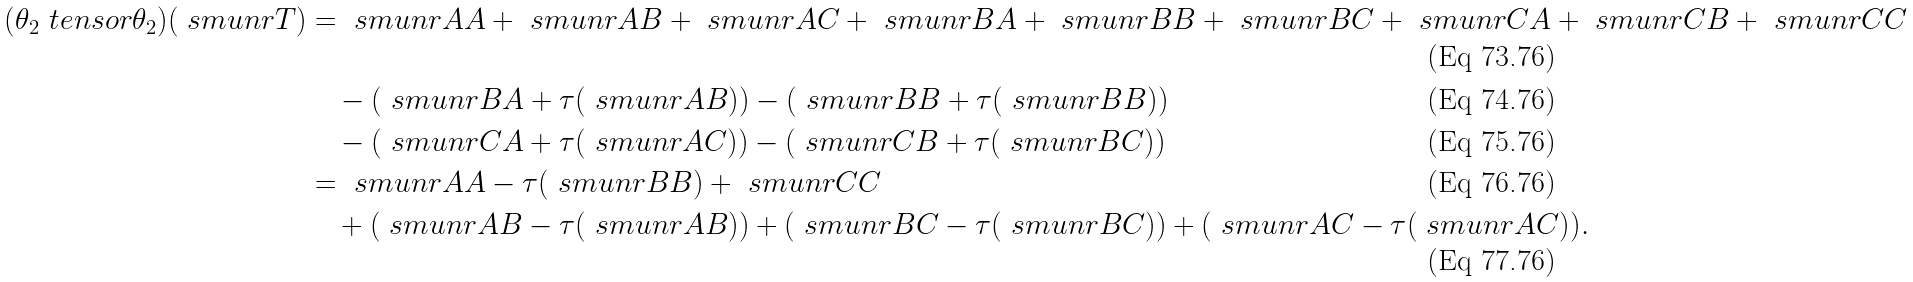Convert formula to latex. <formula><loc_0><loc_0><loc_500><loc_500>( \theta _ { 2 } \ t e n s o r \theta _ { 2 } ) ( \ s m u n { r } { T } ) & = \ s m u n { r } { A A } + \ s m u n { r } { A B } + \ s m u n { r } { A C } + \ s m u n { r } { B A } + \ s m u n { r } { B B } + \ s m u n { r } { B C } + \ s m u n { r } { C A } + \ s m u n { r } { C B } + \ s m u n { r } { C C } \\ & \quad - ( \ s m u n { r } { B A } + \tau ( \ s m u n { r } { A B } ) ) - ( \ s m u n { r } { B B } + \tau ( \ s m u n { r } { B B } ) ) \\ & \quad - ( \ s m u n { r } { C A } + \tau ( \ s m u n { r } { A C } ) ) - ( \ s m u n { r } { C B } + \tau ( \ s m u n { r } { B C } ) ) \\ & = \ s m u n { r } { A A } - \tau ( \ s m u n { r } { B B } ) + \ s m u n { r } { C C } \\ & \quad + ( \ s m u n { r } { A B } - \tau ( \ s m u n { r } { A B } ) ) + ( \ s m u n { r } { B C } - \tau ( \ s m u n { r } { B C } ) ) + ( \ s m u n { r } { A C } - \tau ( \ s m u n { r } { A C } ) ) .</formula> 